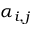<formula> <loc_0><loc_0><loc_500><loc_500>\alpha _ { i , j }</formula> 